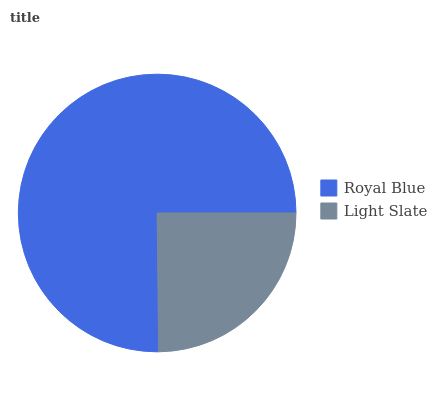Is Light Slate the minimum?
Answer yes or no. Yes. Is Royal Blue the maximum?
Answer yes or no. Yes. Is Light Slate the maximum?
Answer yes or no. No. Is Royal Blue greater than Light Slate?
Answer yes or no. Yes. Is Light Slate less than Royal Blue?
Answer yes or no. Yes. Is Light Slate greater than Royal Blue?
Answer yes or no. No. Is Royal Blue less than Light Slate?
Answer yes or no. No. Is Royal Blue the high median?
Answer yes or no. Yes. Is Light Slate the low median?
Answer yes or no. Yes. Is Light Slate the high median?
Answer yes or no. No. Is Royal Blue the low median?
Answer yes or no. No. 